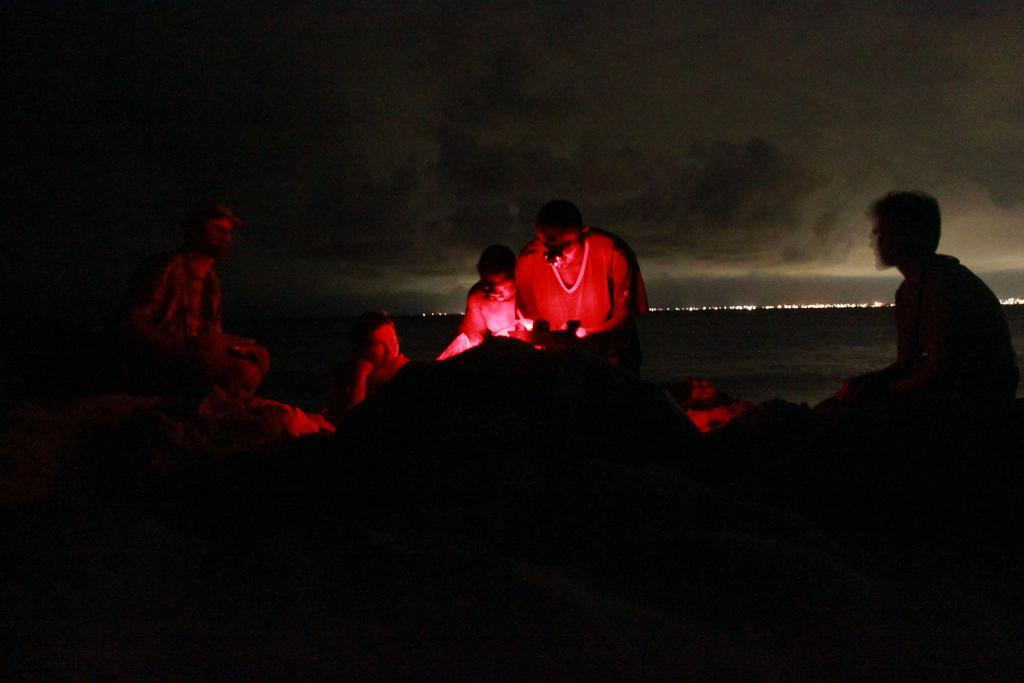What is the overall tone or appearance of the image? The image is dark. Can you describe the subjects in the image? There are people in the image. What natural element is visible in the image? There is water visible in the image. What can be seen in the background of the image? There are lights and the sky visible in the background of the image. What type of bait is being used by the people in the image? There is no mention of bait or fishing in the image, so it cannot be determined what type of bait might be used. Is there a volcano visible in the image? No, there is no volcano present in the image. 